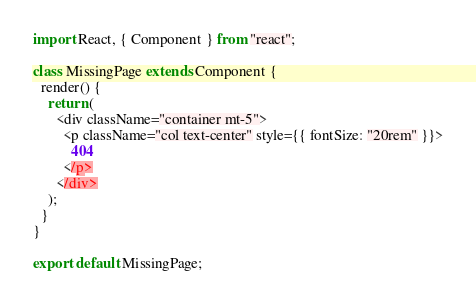Convert code to text. <code><loc_0><loc_0><loc_500><loc_500><_JavaScript_>import React, { Component } from "react";

class MissingPage extends Component {
  render() {
    return (
      <div className="container mt-5">
        <p className="col text-center" style={{ fontSize: "20rem" }}>
          404
        </p>
      </div>
    );
  }
}

export default MissingPage;
</code> 